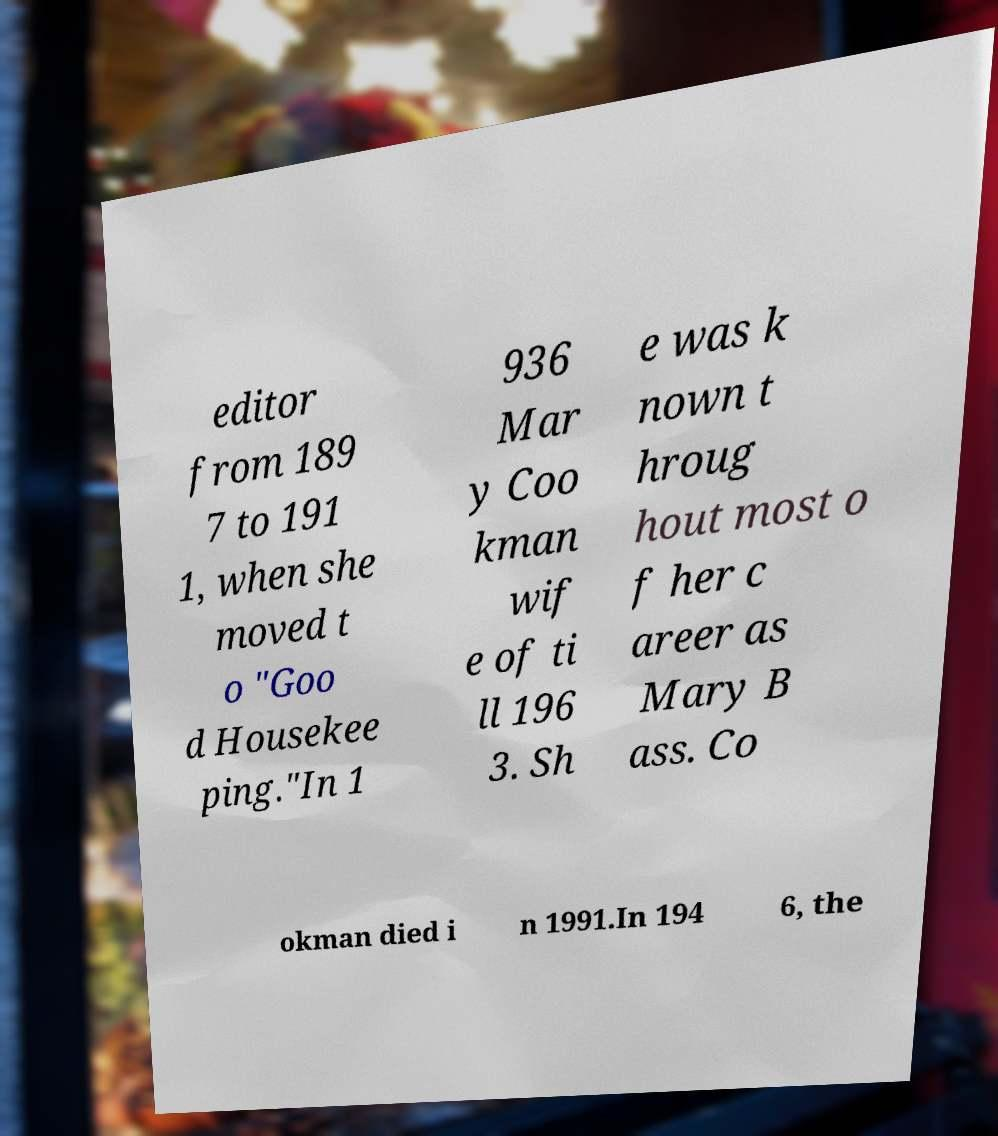Please identify and transcribe the text found in this image. editor from 189 7 to 191 1, when she moved t o "Goo d Housekee ping."In 1 936 Mar y Coo kman wif e of ti ll 196 3. Sh e was k nown t hroug hout most o f her c areer as Mary B ass. Co okman died i n 1991.In 194 6, the 